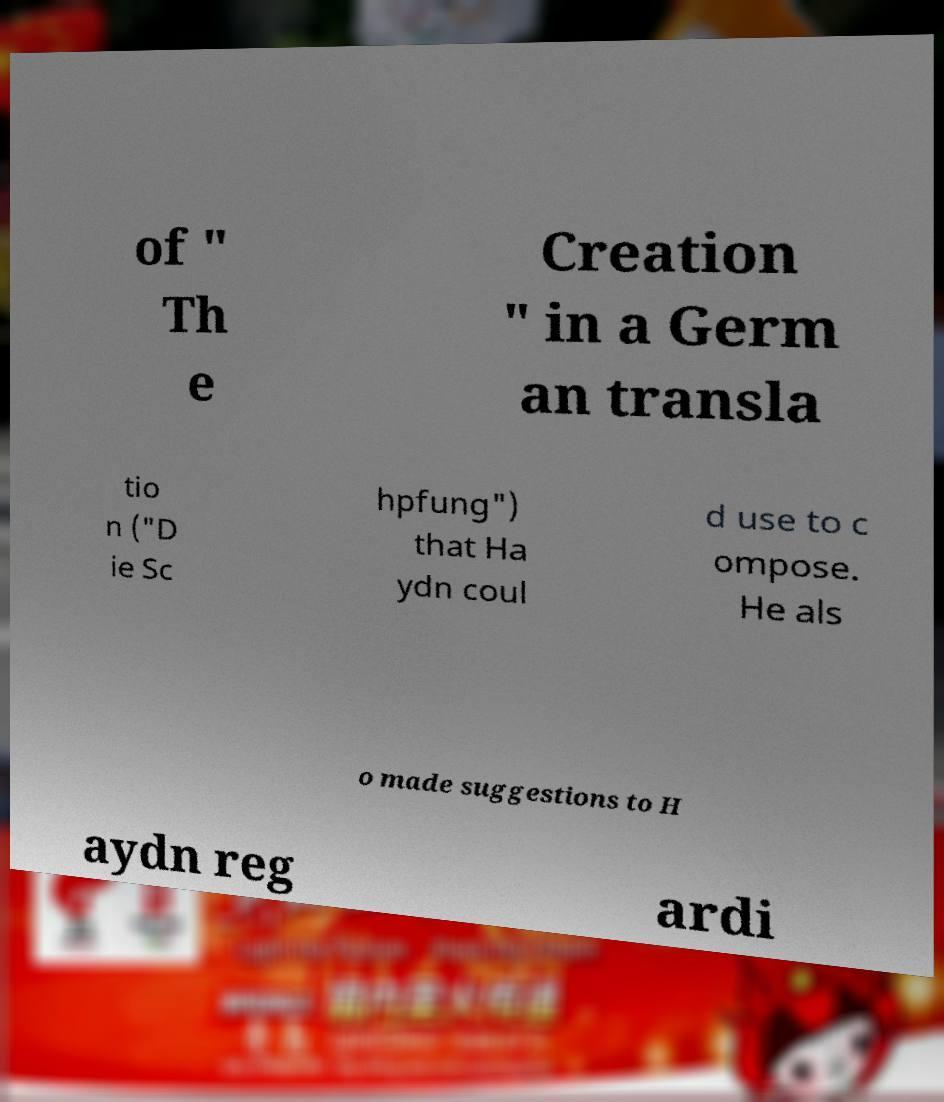Please read and relay the text visible in this image. What does it say? of " Th e Creation " in a Germ an transla tio n ("D ie Sc hpfung") that Ha ydn coul d use to c ompose. He als o made suggestions to H aydn reg ardi 